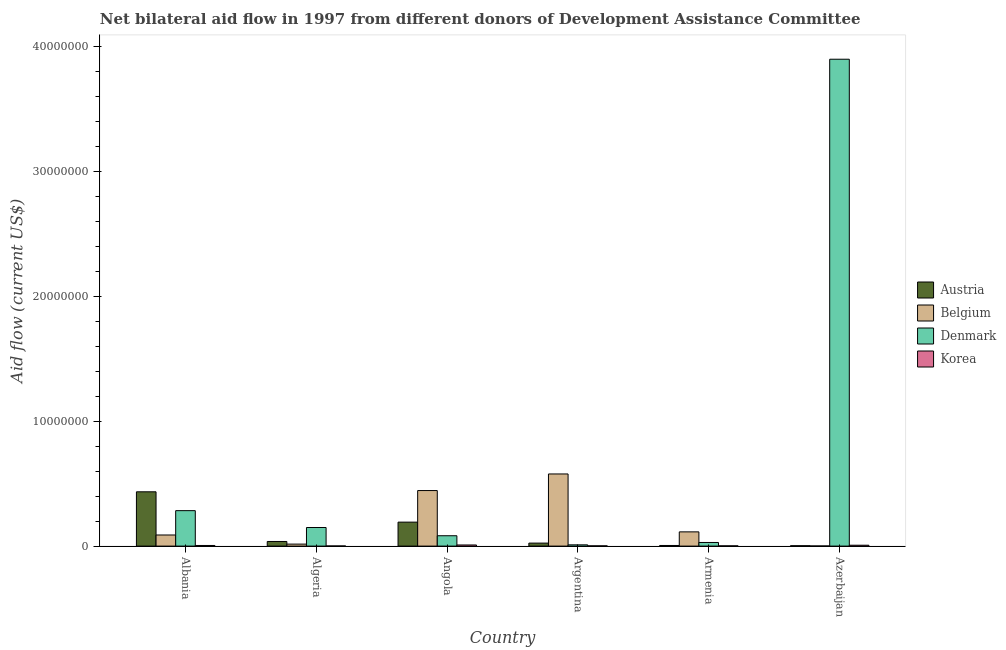How many different coloured bars are there?
Make the answer very short. 4. How many groups of bars are there?
Keep it short and to the point. 6. Are the number of bars per tick equal to the number of legend labels?
Offer a very short reply. Yes. Are the number of bars on each tick of the X-axis equal?
Keep it short and to the point. Yes. What is the label of the 2nd group of bars from the left?
Your response must be concise. Algeria. In how many cases, is the number of bars for a given country not equal to the number of legend labels?
Your answer should be very brief. 0. What is the amount of aid given by belgium in Azerbaijan?
Offer a terse response. 10000. Across all countries, what is the maximum amount of aid given by korea?
Offer a very short reply. 9.00e+04. Across all countries, what is the minimum amount of aid given by korea?
Your answer should be very brief. 10000. In which country was the amount of aid given by korea maximum?
Provide a short and direct response. Angola. In which country was the amount of aid given by denmark minimum?
Ensure brevity in your answer.  Argentina. What is the total amount of aid given by denmark in the graph?
Your answer should be compact. 4.46e+07. What is the difference between the amount of aid given by denmark in Algeria and that in Argentina?
Offer a very short reply. 1.39e+06. What is the difference between the amount of aid given by korea in Algeria and the amount of aid given by denmark in Armenia?
Keep it short and to the point. -2.80e+05. What is the average amount of aid given by austria per country?
Your answer should be very brief. 1.16e+06. What is the difference between the amount of aid given by denmark and amount of aid given by belgium in Armenia?
Make the answer very short. -8.50e+05. What is the ratio of the amount of aid given by denmark in Albania to that in Armenia?
Your answer should be very brief. 9.79. Is the amount of aid given by austria in Albania less than that in Armenia?
Give a very brief answer. No. Is the difference between the amount of aid given by belgium in Angola and Armenia greater than the difference between the amount of aid given by korea in Angola and Armenia?
Offer a terse response. Yes. What is the difference between the highest and the second highest amount of aid given by belgium?
Your answer should be compact. 1.33e+06. What is the difference between the highest and the lowest amount of aid given by denmark?
Provide a succinct answer. 3.89e+07. In how many countries, is the amount of aid given by korea greater than the average amount of aid given by korea taken over all countries?
Ensure brevity in your answer.  3. Is the sum of the amount of aid given by korea in Armenia and Azerbaijan greater than the maximum amount of aid given by belgium across all countries?
Offer a very short reply. No. Is it the case that in every country, the sum of the amount of aid given by korea and amount of aid given by denmark is greater than the sum of amount of aid given by austria and amount of aid given by belgium?
Your answer should be compact. Yes. What does the 2nd bar from the left in Algeria represents?
Offer a very short reply. Belgium. What does the 3rd bar from the right in Armenia represents?
Give a very brief answer. Belgium. Is it the case that in every country, the sum of the amount of aid given by austria and amount of aid given by belgium is greater than the amount of aid given by denmark?
Ensure brevity in your answer.  No. Are all the bars in the graph horizontal?
Your answer should be very brief. No. How many countries are there in the graph?
Provide a succinct answer. 6. Where does the legend appear in the graph?
Your answer should be very brief. Center right. How many legend labels are there?
Provide a succinct answer. 4. What is the title of the graph?
Your response must be concise. Net bilateral aid flow in 1997 from different donors of Development Assistance Committee. What is the label or title of the X-axis?
Provide a succinct answer. Country. What is the Aid flow (current US$) of Austria in Albania?
Offer a terse response. 4.35e+06. What is the Aid flow (current US$) in Belgium in Albania?
Offer a terse response. 8.90e+05. What is the Aid flow (current US$) in Denmark in Albania?
Offer a terse response. 2.84e+06. What is the Aid flow (current US$) in Austria in Algeria?
Your answer should be compact. 3.70e+05. What is the Aid flow (current US$) of Belgium in Algeria?
Your answer should be compact. 1.60e+05. What is the Aid flow (current US$) in Denmark in Algeria?
Give a very brief answer. 1.49e+06. What is the Aid flow (current US$) of Austria in Angola?
Ensure brevity in your answer.  1.92e+06. What is the Aid flow (current US$) of Belgium in Angola?
Your answer should be very brief. 4.45e+06. What is the Aid flow (current US$) in Denmark in Angola?
Offer a very short reply. 8.30e+05. What is the Aid flow (current US$) of Belgium in Argentina?
Make the answer very short. 5.78e+06. What is the Aid flow (current US$) of Korea in Argentina?
Your response must be concise. 2.00e+04. What is the Aid flow (current US$) of Austria in Armenia?
Your response must be concise. 5.00e+04. What is the Aid flow (current US$) of Belgium in Armenia?
Keep it short and to the point. 1.14e+06. What is the Aid flow (current US$) of Korea in Armenia?
Provide a succinct answer. 2.00e+04. What is the Aid flow (current US$) in Austria in Azerbaijan?
Your answer should be very brief. 3.00e+04. What is the Aid flow (current US$) in Denmark in Azerbaijan?
Your answer should be very brief. 3.90e+07. Across all countries, what is the maximum Aid flow (current US$) in Austria?
Your answer should be very brief. 4.35e+06. Across all countries, what is the maximum Aid flow (current US$) of Belgium?
Your response must be concise. 5.78e+06. Across all countries, what is the maximum Aid flow (current US$) of Denmark?
Your answer should be compact. 3.90e+07. Across all countries, what is the minimum Aid flow (current US$) in Austria?
Your answer should be compact. 3.00e+04. Across all countries, what is the minimum Aid flow (current US$) in Denmark?
Ensure brevity in your answer.  1.00e+05. Across all countries, what is the minimum Aid flow (current US$) in Korea?
Your answer should be compact. 10000. What is the total Aid flow (current US$) in Austria in the graph?
Your answer should be very brief. 6.96e+06. What is the total Aid flow (current US$) of Belgium in the graph?
Offer a very short reply. 1.24e+07. What is the total Aid flow (current US$) in Denmark in the graph?
Your answer should be very brief. 4.46e+07. What is the total Aid flow (current US$) in Korea in the graph?
Make the answer very short. 2.60e+05. What is the difference between the Aid flow (current US$) in Austria in Albania and that in Algeria?
Ensure brevity in your answer.  3.98e+06. What is the difference between the Aid flow (current US$) in Belgium in Albania and that in Algeria?
Give a very brief answer. 7.30e+05. What is the difference between the Aid flow (current US$) in Denmark in Albania and that in Algeria?
Make the answer very short. 1.35e+06. What is the difference between the Aid flow (current US$) in Korea in Albania and that in Algeria?
Keep it short and to the point. 4.00e+04. What is the difference between the Aid flow (current US$) in Austria in Albania and that in Angola?
Your answer should be very brief. 2.43e+06. What is the difference between the Aid flow (current US$) of Belgium in Albania and that in Angola?
Keep it short and to the point. -3.56e+06. What is the difference between the Aid flow (current US$) of Denmark in Albania and that in Angola?
Give a very brief answer. 2.01e+06. What is the difference between the Aid flow (current US$) in Austria in Albania and that in Argentina?
Offer a very short reply. 4.11e+06. What is the difference between the Aid flow (current US$) of Belgium in Albania and that in Argentina?
Give a very brief answer. -4.89e+06. What is the difference between the Aid flow (current US$) of Denmark in Albania and that in Argentina?
Provide a short and direct response. 2.74e+06. What is the difference between the Aid flow (current US$) in Austria in Albania and that in Armenia?
Offer a very short reply. 4.30e+06. What is the difference between the Aid flow (current US$) in Belgium in Albania and that in Armenia?
Your answer should be compact. -2.50e+05. What is the difference between the Aid flow (current US$) of Denmark in Albania and that in Armenia?
Your answer should be very brief. 2.55e+06. What is the difference between the Aid flow (current US$) of Korea in Albania and that in Armenia?
Provide a succinct answer. 3.00e+04. What is the difference between the Aid flow (current US$) of Austria in Albania and that in Azerbaijan?
Give a very brief answer. 4.32e+06. What is the difference between the Aid flow (current US$) in Belgium in Albania and that in Azerbaijan?
Keep it short and to the point. 8.80e+05. What is the difference between the Aid flow (current US$) in Denmark in Albania and that in Azerbaijan?
Ensure brevity in your answer.  -3.62e+07. What is the difference between the Aid flow (current US$) in Korea in Albania and that in Azerbaijan?
Give a very brief answer. -2.00e+04. What is the difference between the Aid flow (current US$) of Austria in Algeria and that in Angola?
Your response must be concise. -1.55e+06. What is the difference between the Aid flow (current US$) of Belgium in Algeria and that in Angola?
Offer a very short reply. -4.29e+06. What is the difference between the Aid flow (current US$) of Denmark in Algeria and that in Angola?
Ensure brevity in your answer.  6.60e+05. What is the difference between the Aid flow (current US$) of Belgium in Algeria and that in Argentina?
Your answer should be very brief. -5.62e+06. What is the difference between the Aid flow (current US$) in Denmark in Algeria and that in Argentina?
Provide a succinct answer. 1.39e+06. What is the difference between the Aid flow (current US$) in Austria in Algeria and that in Armenia?
Offer a terse response. 3.20e+05. What is the difference between the Aid flow (current US$) of Belgium in Algeria and that in Armenia?
Offer a very short reply. -9.80e+05. What is the difference between the Aid flow (current US$) in Denmark in Algeria and that in Armenia?
Ensure brevity in your answer.  1.20e+06. What is the difference between the Aid flow (current US$) in Korea in Algeria and that in Armenia?
Offer a very short reply. -10000. What is the difference between the Aid flow (current US$) of Denmark in Algeria and that in Azerbaijan?
Offer a very short reply. -3.75e+07. What is the difference between the Aid flow (current US$) of Austria in Angola and that in Argentina?
Offer a very short reply. 1.68e+06. What is the difference between the Aid flow (current US$) of Belgium in Angola and that in Argentina?
Ensure brevity in your answer.  -1.33e+06. What is the difference between the Aid flow (current US$) in Denmark in Angola and that in Argentina?
Ensure brevity in your answer.  7.30e+05. What is the difference between the Aid flow (current US$) in Austria in Angola and that in Armenia?
Your answer should be very brief. 1.87e+06. What is the difference between the Aid flow (current US$) of Belgium in Angola and that in Armenia?
Provide a short and direct response. 3.31e+06. What is the difference between the Aid flow (current US$) of Denmark in Angola and that in Armenia?
Provide a succinct answer. 5.40e+05. What is the difference between the Aid flow (current US$) in Korea in Angola and that in Armenia?
Provide a succinct answer. 7.00e+04. What is the difference between the Aid flow (current US$) in Austria in Angola and that in Azerbaijan?
Keep it short and to the point. 1.89e+06. What is the difference between the Aid flow (current US$) in Belgium in Angola and that in Azerbaijan?
Give a very brief answer. 4.44e+06. What is the difference between the Aid flow (current US$) in Denmark in Angola and that in Azerbaijan?
Give a very brief answer. -3.82e+07. What is the difference between the Aid flow (current US$) of Korea in Angola and that in Azerbaijan?
Your response must be concise. 2.00e+04. What is the difference between the Aid flow (current US$) of Austria in Argentina and that in Armenia?
Ensure brevity in your answer.  1.90e+05. What is the difference between the Aid flow (current US$) of Belgium in Argentina and that in Armenia?
Offer a terse response. 4.64e+06. What is the difference between the Aid flow (current US$) of Denmark in Argentina and that in Armenia?
Make the answer very short. -1.90e+05. What is the difference between the Aid flow (current US$) in Austria in Argentina and that in Azerbaijan?
Offer a terse response. 2.10e+05. What is the difference between the Aid flow (current US$) in Belgium in Argentina and that in Azerbaijan?
Give a very brief answer. 5.77e+06. What is the difference between the Aid flow (current US$) in Denmark in Argentina and that in Azerbaijan?
Your answer should be very brief. -3.89e+07. What is the difference between the Aid flow (current US$) of Austria in Armenia and that in Azerbaijan?
Ensure brevity in your answer.  2.00e+04. What is the difference between the Aid flow (current US$) of Belgium in Armenia and that in Azerbaijan?
Ensure brevity in your answer.  1.13e+06. What is the difference between the Aid flow (current US$) in Denmark in Armenia and that in Azerbaijan?
Make the answer very short. -3.87e+07. What is the difference between the Aid flow (current US$) of Austria in Albania and the Aid flow (current US$) of Belgium in Algeria?
Your response must be concise. 4.19e+06. What is the difference between the Aid flow (current US$) of Austria in Albania and the Aid flow (current US$) of Denmark in Algeria?
Provide a short and direct response. 2.86e+06. What is the difference between the Aid flow (current US$) in Austria in Albania and the Aid flow (current US$) in Korea in Algeria?
Offer a very short reply. 4.34e+06. What is the difference between the Aid flow (current US$) in Belgium in Albania and the Aid flow (current US$) in Denmark in Algeria?
Offer a terse response. -6.00e+05. What is the difference between the Aid flow (current US$) of Belgium in Albania and the Aid flow (current US$) of Korea in Algeria?
Ensure brevity in your answer.  8.80e+05. What is the difference between the Aid flow (current US$) in Denmark in Albania and the Aid flow (current US$) in Korea in Algeria?
Make the answer very short. 2.83e+06. What is the difference between the Aid flow (current US$) of Austria in Albania and the Aid flow (current US$) of Denmark in Angola?
Your response must be concise. 3.52e+06. What is the difference between the Aid flow (current US$) in Austria in Albania and the Aid flow (current US$) in Korea in Angola?
Your answer should be very brief. 4.26e+06. What is the difference between the Aid flow (current US$) in Belgium in Albania and the Aid flow (current US$) in Korea in Angola?
Keep it short and to the point. 8.00e+05. What is the difference between the Aid flow (current US$) of Denmark in Albania and the Aid flow (current US$) of Korea in Angola?
Give a very brief answer. 2.75e+06. What is the difference between the Aid flow (current US$) in Austria in Albania and the Aid flow (current US$) in Belgium in Argentina?
Provide a succinct answer. -1.43e+06. What is the difference between the Aid flow (current US$) of Austria in Albania and the Aid flow (current US$) of Denmark in Argentina?
Keep it short and to the point. 4.25e+06. What is the difference between the Aid flow (current US$) of Austria in Albania and the Aid flow (current US$) of Korea in Argentina?
Keep it short and to the point. 4.33e+06. What is the difference between the Aid flow (current US$) in Belgium in Albania and the Aid flow (current US$) in Denmark in Argentina?
Offer a very short reply. 7.90e+05. What is the difference between the Aid flow (current US$) of Belgium in Albania and the Aid flow (current US$) of Korea in Argentina?
Offer a terse response. 8.70e+05. What is the difference between the Aid flow (current US$) of Denmark in Albania and the Aid flow (current US$) of Korea in Argentina?
Provide a short and direct response. 2.82e+06. What is the difference between the Aid flow (current US$) of Austria in Albania and the Aid flow (current US$) of Belgium in Armenia?
Offer a terse response. 3.21e+06. What is the difference between the Aid flow (current US$) in Austria in Albania and the Aid flow (current US$) in Denmark in Armenia?
Offer a very short reply. 4.06e+06. What is the difference between the Aid flow (current US$) of Austria in Albania and the Aid flow (current US$) of Korea in Armenia?
Offer a terse response. 4.33e+06. What is the difference between the Aid flow (current US$) in Belgium in Albania and the Aid flow (current US$) in Korea in Armenia?
Your answer should be compact. 8.70e+05. What is the difference between the Aid flow (current US$) of Denmark in Albania and the Aid flow (current US$) of Korea in Armenia?
Ensure brevity in your answer.  2.82e+06. What is the difference between the Aid flow (current US$) in Austria in Albania and the Aid flow (current US$) in Belgium in Azerbaijan?
Your answer should be compact. 4.34e+06. What is the difference between the Aid flow (current US$) of Austria in Albania and the Aid flow (current US$) of Denmark in Azerbaijan?
Keep it short and to the point. -3.47e+07. What is the difference between the Aid flow (current US$) in Austria in Albania and the Aid flow (current US$) in Korea in Azerbaijan?
Offer a terse response. 4.28e+06. What is the difference between the Aid flow (current US$) in Belgium in Albania and the Aid flow (current US$) in Denmark in Azerbaijan?
Offer a terse response. -3.81e+07. What is the difference between the Aid flow (current US$) of Belgium in Albania and the Aid flow (current US$) of Korea in Azerbaijan?
Offer a very short reply. 8.20e+05. What is the difference between the Aid flow (current US$) of Denmark in Albania and the Aid flow (current US$) of Korea in Azerbaijan?
Offer a terse response. 2.77e+06. What is the difference between the Aid flow (current US$) in Austria in Algeria and the Aid flow (current US$) in Belgium in Angola?
Your answer should be very brief. -4.08e+06. What is the difference between the Aid flow (current US$) of Austria in Algeria and the Aid flow (current US$) of Denmark in Angola?
Keep it short and to the point. -4.60e+05. What is the difference between the Aid flow (current US$) in Austria in Algeria and the Aid flow (current US$) in Korea in Angola?
Your answer should be very brief. 2.80e+05. What is the difference between the Aid flow (current US$) of Belgium in Algeria and the Aid flow (current US$) of Denmark in Angola?
Your response must be concise. -6.70e+05. What is the difference between the Aid flow (current US$) in Denmark in Algeria and the Aid flow (current US$) in Korea in Angola?
Provide a short and direct response. 1.40e+06. What is the difference between the Aid flow (current US$) in Austria in Algeria and the Aid flow (current US$) in Belgium in Argentina?
Provide a short and direct response. -5.41e+06. What is the difference between the Aid flow (current US$) in Austria in Algeria and the Aid flow (current US$) in Denmark in Argentina?
Ensure brevity in your answer.  2.70e+05. What is the difference between the Aid flow (current US$) of Denmark in Algeria and the Aid flow (current US$) of Korea in Argentina?
Your answer should be very brief. 1.47e+06. What is the difference between the Aid flow (current US$) in Austria in Algeria and the Aid flow (current US$) in Belgium in Armenia?
Offer a terse response. -7.70e+05. What is the difference between the Aid flow (current US$) of Austria in Algeria and the Aid flow (current US$) of Denmark in Armenia?
Offer a terse response. 8.00e+04. What is the difference between the Aid flow (current US$) in Belgium in Algeria and the Aid flow (current US$) in Denmark in Armenia?
Offer a terse response. -1.30e+05. What is the difference between the Aid flow (current US$) in Denmark in Algeria and the Aid flow (current US$) in Korea in Armenia?
Keep it short and to the point. 1.47e+06. What is the difference between the Aid flow (current US$) of Austria in Algeria and the Aid flow (current US$) of Belgium in Azerbaijan?
Make the answer very short. 3.60e+05. What is the difference between the Aid flow (current US$) of Austria in Algeria and the Aid flow (current US$) of Denmark in Azerbaijan?
Keep it short and to the point. -3.86e+07. What is the difference between the Aid flow (current US$) in Belgium in Algeria and the Aid flow (current US$) in Denmark in Azerbaijan?
Keep it short and to the point. -3.88e+07. What is the difference between the Aid flow (current US$) of Denmark in Algeria and the Aid flow (current US$) of Korea in Azerbaijan?
Your response must be concise. 1.42e+06. What is the difference between the Aid flow (current US$) in Austria in Angola and the Aid flow (current US$) in Belgium in Argentina?
Your answer should be compact. -3.86e+06. What is the difference between the Aid flow (current US$) of Austria in Angola and the Aid flow (current US$) of Denmark in Argentina?
Your response must be concise. 1.82e+06. What is the difference between the Aid flow (current US$) in Austria in Angola and the Aid flow (current US$) in Korea in Argentina?
Your answer should be very brief. 1.90e+06. What is the difference between the Aid flow (current US$) of Belgium in Angola and the Aid flow (current US$) of Denmark in Argentina?
Ensure brevity in your answer.  4.35e+06. What is the difference between the Aid flow (current US$) in Belgium in Angola and the Aid flow (current US$) in Korea in Argentina?
Keep it short and to the point. 4.43e+06. What is the difference between the Aid flow (current US$) of Denmark in Angola and the Aid flow (current US$) of Korea in Argentina?
Provide a succinct answer. 8.10e+05. What is the difference between the Aid flow (current US$) of Austria in Angola and the Aid flow (current US$) of Belgium in Armenia?
Offer a terse response. 7.80e+05. What is the difference between the Aid flow (current US$) in Austria in Angola and the Aid flow (current US$) in Denmark in Armenia?
Ensure brevity in your answer.  1.63e+06. What is the difference between the Aid flow (current US$) in Austria in Angola and the Aid flow (current US$) in Korea in Armenia?
Offer a terse response. 1.90e+06. What is the difference between the Aid flow (current US$) of Belgium in Angola and the Aid flow (current US$) of Denmark in Armenia?
Make the answer very short. 4.16e+06. What is the difference between the Aid flow (current US$) in Belgium in Angola and the Aid flow (current US$) in Korea in Armenia?
Give a very brief answer. 4.43e+06. What is the difference between the Aid flow (current US$) of Denmark in Angola and the Aid flow (current US$) of Korea in Armenia?
Provide a short and direct response. 8.10e+05. What is the difference between the Aid flow (current US$) of Austria in Angola and the Aid flow (current US$) of Belgium in Azerbaijan?
Your response must be concise. 1.91e+06. What is the difference between the Aid flow (current US$) of Austria in Angola and the Aid flow (current US$) of Denmark in Azerbaijan?
Make the answer very short. -3.71e+07. What is the difference between the Aid flow (current US$) in Austria in Angola and the Aid flow (current US$) in Korea in Azerbaijan?
Keep it short and to the point. 1.85e+06. What is the difference between the Aid flow (current US$) in Belgium in Angola and the Aid flow (current US$) in Denmark in Azerbaijan?
Your answer should be compact. -3.46e+07. What is the difference between the Aid flow (current US$) of Belgium in Angola and the Aid flow (current US$) of Korea in Azerbaijan?
Make the answer very short. 4.38e+06. What is the difference between the Aid flow (current US$) in Denmark in Angola and the Aid flow (current US$) in Korea in Azerbaijan?
Your response must be concise. 7.60e+05. What is the difference between the Aid flow (current US$) in Austria in Argentina and the Aid flow (current US$) in Belgium in Armenia?
Keep it short and to the point. -9.00e+05. What is the difference between the Aid flow (current US$) of Austria in Argentina and the Aid flow (current US$) of Denmark in Armenia?
Give a very brief answer. -5.00e+04. What is the difference between the Aid flow (current US$) in Belgium in Argentina and the Aid flow (current US$) in Denmark in Armenia?
Give a very brief answer. 5.49e+06. What is the difference between the Aid flow (current US$) in Belgium in Argentina and the Aid flow (current US$) in Korea in Armenia?
Ensure brevity in your answer.  5.76e+06. What is the difference between the Aid flow (current US$) of Denmark in Argentina and the Aid flow (current US$) of Korea in Armenia?
Your response must be concise. 8.00e+04. What is the difference between the Aid flow (current US$) in Austria in Argentina and the Aid flow (current US$) in Belgium in Azerbaijan?
Provide a succinct answer. 2.30e+05. What is the difference between the Aid flow (current US$) of Austria in Argentina and the Aid flow (current US$) of Denmark in Azerbaijan?
Provide a succinct answer. -3.88e+07. What is the difference between the Aid flow (current US$) of Austria in Argentina and the Aid flow (current US$) of Korea in Azerbaijan?
Ensure brevity in your answer.  1.70e+05. What is the difference between the Aid flow (current US$) of Belgium in Argentina and the Aid flow (current US$) of Denmark in Azerbaijan?
Your response must be concise. -3.32e+07. What is the difference between the Aid flow (current US$) of Belgium in Argentina and the Aid flow (current US$) of Korea in Azerbaijan?
Give a very brief answer. 5.71e+06. What is the difference between the Aid flow (current US$) in Austria in Armenia and the Aid flow (current US$) in Denmark in Azerbaijan?
Provide a short and direct response. -3.90e+07. What is the difference between the Aid flow (current US$) in Belgium in Armenia and the Aid flow (current US$) in Denmark in Azerbaijan?
Keep it short and to the point. -3.79e+07. What is the difference between the Aid flow (current US$) of Belgium in Armenia and the Aid flow (current US$) of Korea in Azerbaijan?
Your response must be concise. 1.07e+06. What is the average Aid flow (current US$) of Austria per country?
Make the answer very short. 1.16e+06. What is the average Aid flow (current US$) in Belgium per country?
Give a very brief answer. 2.07e+06. What is the average Aid flow (current US$) in Denmark per country?
Offer a terse response. 7.43e+06. What is the average Aid flow (current US$) of Korea per country?
Provide a short and direct response. 4.33e+04. What is the difference between the Aid flow (current US$) of Austria and Aid flow (current US$) of Belgium in Albania?
Your answer should be compact. 3.46e+06. What is the difference between the Aid flow (current US$) in Austria and Aid flow (current US$) in Denmark in Albania?
Your answer should be very brief. 1.51e+06. What is the difference between the Aid flow (current US$) in Austria and Aid flow (current US$) in Korea in Albania?
Offer a terse response. 4.30e+06. What is the difference between the Aid flow (current US$) in Belgium and Aid flow (current US$) in Denmark in Albania?
Provide a short and direct response. -1.95e+06. What is the difference between the Aid flow (current US$) in Belgium and Aid flow (current US$) in Korea in Albania?
Offer a very short reply. 8.40e+05. What is the difference between the Aid flow (current US$) of Denmark and Aid flow (current US$) of Korea in Albania?
Provide a succinct answer. 2.79e+06. What is the difference between the Aid flow (current US$) of Austria and Aid flow (current US$) of Denmark in Algeria?
Give a very brief answer. -1.12e+06. What is the difference between the Aid flow (current US$) of Belgium and Aid flow (current US$) of Denmark in Algeria?
Your answer should be very brief. -1.33e+06. What is the difference between the Aid flow (current US$) in Belgium and Aid flow (current US$) in Korea in Algeria?
Provide a short and direct response. 1.50e+05. What is the difference between the Aid flow (current US$) of Denmark and Aid flow (current US$) of Korea in Algeria?
Keep it short and to the point. 1.48e+06. What is the difference between the Aid flow (current US$) of Austria and Aid flow (current US$) of Belgium in Angola?
Provide a succinct answer. -2.53e+06. What is the difference between the Aid flow (current US$) in Austria and Aid flow (current US$) in Denmark in Angola?
Offer a very short reply. 1.09e+06. What is the difference between the Aid flow (current US$) of Austria and Aid flow (current US$) of Korea in Angola?
Keep it short and to the point. 1.83e+06. What is the difference between the Aid flow (current US$) in Belgium and Aid flow (current US$) in Denmark in Angola?
Make the answer very short. 3.62e+06. What is the difference between the Aid flow (current US$) of Belgium and Aid flow (current US$) of Korea in Angola?
Provide a short and direct response. 4.36e+06. What is the difference between the Aid flow (current US$) in Denmark and Aid flow (current US$) in Korea in Angola?
Give a very brief answer. 7.40e+05. What is the difference between the Aid flow (current US$) in Austria and Aid flow (current US$) in Belgium in Argentina?
Provide a short and direct response. -5.54e+06. What is the difference between the Aid flow (current US$) of Austria and Aid flow (current US$) of Denmark in Argentina?
Make the answer very short. 1.40e+05. What is the difference between the Aid flow (current US$) of Austria and Aid flow (current US$) of Korea in Argentina?
Offer a terse response. 2.20e+05. What is the difference between the Aid flow (current US$) of Belgium and Aid flow (current US$) of Denmark in Argentina?
Your answer should be very brief. 5.68e+06. What is the difference between the Aid flow (current US$) in Belgium and Aid flow (current US$) in Korea in Argentina?
Keep it short and to the point. 5.76e+06. What is the difference between the Aid flow (current US$) in Denmark and Aid flow (current US$) in Korea in Argentina?
Offer a very short reply. 8.00e+04. What is the difference between the Aid flow (current US$) in Austria and Aid flow (current US$) in Belgium in Armenia?
Provide a succinct answer. -1.09e+06. What is the difference between the Aid flow (current US$) in Austria and Aid flow (current US$) in Denmark in Armenia?
Your response must be concise. -2.40e+05. What is the difference between the Aid flow (current US$) in Austria and Aid flow (current US$) in Korea in Armenia?
Your answer should be very brief. 3.00e+04. What is the difference between the Aid flow (current US$) of Belgium and Aid flow (current US$) of Denmark in Armenia?
Give a very brief answer. 8.50e+05. What is the difference between the Aid flow (current US$) of Belgium and Aid flow (current US$) of Korea in Armenia?
Your answer should be very brief. 1.12e+06. What is the difference between the Aid flow (current US$) in Austria and Aid flow (current US$) in Denmark in Azerbaijan?
Ensure brevity in your answer.  -3.90e+07. What is the difference between the Aid flow (current US$) of Belgium and Aid flow (current US$) of Denmark in Azerbaijan?
Your answer should be compact. -3.90e+07. What is the difference between the Aid flow (current US$) of Denmark and Aid flow (current US$) of Korea in Azerbaijan?
Offer a very short reply. 3.89e+07. What is the ratio of the Aid flow (current US$) in Austria in Albania to that in Algeria?
Give a very brief answer. 11.76. What is the ratio of the Aid flow (current US$) of Belgium in Albania to that in Algeria?
Provide a short and direct response. 5.56. What is the ratio of the Aid flow (current US$) of Denmark in Albania to that in Algeria?
Ensure brevity in your answer.  1.91. What is the ratio of the Aid flow (current US$) in Korea in Albania to that in Algeria?
Ensure brevity in your answer.  5. What is the ratio of the Aid flow (current US$) in Austria in Albania to that in Angola?
Give a very brief answer. 2.27. What is the ratio of the Aid flow (current US$) in Denmark in Albania to that in Angola?
Your answer should be compact. 3.42. What is the ratio of the Aid flow (current US$) in Korea in Albania to that in Angola?
Keep it short and to the point. 0.56. What is the ratio of the Aid flow (current US$) of Austria in Albania to that in Argentina?
Make the answer very short. 18.12. What is the ratio of the Aid flow (current US$) in Belgium in Albania to that in Argentina?
Offer a very short reply. 0.15. What is the ratio of the Aid flow (current US$) in Denmark in Albania to that in Argentina?
Your answer should be compact. 28.4. What is the ratio of the Aid flow (current US$) of Korea in Albania to that in Argentina?
Your answer should be compact. 2.5. What is the ratio of the Aid flow (current US$) in Belgium in Albania to that in Armenia?
Provide a short and direct response. 0.78. What is the ratio of the Aid flow (current US$) of Denmark in Albania to that in Armenia?
Provide a succinct answer. 9.79. What is the ratio of the Aid flow (current US$) of Austria in Albania to that in Azerbaijan?
Keep it short and to the point. 145. What is the ratio of the Aid flow (current US$) of Belgium in Albania to that in Azerbaijan?
Your answer should be very brief. 89. What is the ratio of the Aid flow (current US$) of Denmark in Albania to that in Azerbaijan?
Give a very brief answer. 0.07. What is the ratio of the Aid flow (current US$) of Korea in Albania to that in Azerbaijan?
Provide a succinct answer. 0.71. What is the ratio of the Aid flow (current US$) in Austria in Algeria to that in Angola?
Your response must be concise. 0.19. What is the ratio of the Aid flow (current US$) in Belgium in Algeria to that in Angola?
Make the answer very short. 0.04. What is the ratio of the Aid flow (current US$) in Denmark in Algeria to that in Angola?
Keep it short and to the point. 1.8. What is the ratio of the Aid flow (current US$) in Korea in Algeria to that in Angola?
Provide a short and direct response. 0.11. What is the ratio of the Aid flow (current US$) of Austria in Algeria to that in Argentina?
Provide a succinct answer. 1.54. What is the ratio of the Aid flow (current US$) in Belgium in Algeria to that in Argentina?
Make the answer very short. 0.03. What is the ratio of the Aid flow (current US$) of Belgium in Algeria to that in Armenia?
Make the answer very short. 0.14. What is the ratio of the Aid flow (current US$) of Denmark in Algeria to that in Armenia?
Offer a very short reply. 5.14. What is the ratio of the Aid flow (current US$) of Korea in Algeria to that in Armenia?
Offer a very short reply. 0.5. What is the ratio of the Aid flow (current US$) of Austria in Algeria to that in Azerbaijan?
Provide a succinct answer. 12.33. What is the ratio of the Aid flow (current US$) of Denmark in Algeria to that in Azerbaijan?
Your answer should be compact. 0.04. What is the ratio of the Aid flow (current US$) in Korea in Algeria to that in Azerbaijan?
Your answer should be very brief. 0.14. What is the ratio of the Aid flow (current US$) in Belgium in Angola to that in Argentina?
Give a very brief answer. 0.77. What is the ratio of the Aid flow (current US$) of Denmark in Angola to that in Argentina?
Your answer should be very brief. 8.3. What is the ratio of the Aid flow (current US$) in Korea in Angola to that in Argentina?
Your answer should be compact. 4.5. What is the ratio of the Aid flow (current US$) in Austria in Angola to that in Armenia?
Keep it short and to the point. 38.4. What is the ratio of the Aid flow (current US$) of Belgium in Angola to that in Armenia?
Provide a short and direct response. 3.9. What is the ratio of the Aid flow (current US$) in Denmark in Angola to that in Armenia?
Provide a short and direct response. 2.86. What is the ratio of the Aid flow (current US$) of Austria in Angola to that in Azerbaijan?
Your answer should be compact. 64. What is the ratio of the Aid flow (current US$) in Belgium in Angola to that in Azerbaijan?
Your answer should be compact. 445. What is the ratio of the Aid flow (current US$) in Denmark in Angola to that in Azerbaijan?
Keep it short and to the point. 0.02. What is the ratio of the Aid flow (current US$) in Belgium in Argentina to that in Armenia?
Provide a short and direct response. 5.07. What is the ratio of the Aid flow (current US$) of Denmark in Argentina to that in Armenia?
Offer a terse response. 0.34. What is the ratio of the Aid flow (current US$) in Korea in Argentina to that in Armenia?
Your response must be concise. 1. What is the ratio of the Aid flow (current US$) of Austria in Argentina to that in Azerbaijan?
Offer a terse response. 8. What is the ratio of the Aid flow (current US$) in Belgium in Argentina to that in Azerbaijan?
Your answer should be very brief. 578. What is the ratio of the Aid flow (current US$) of Denmark in Argentina to that in Azerbaijan?
Give a very brief answer. 0. What is the ratio of the Aid flow (current US$) of Korea in Argentina to that in Azerbaijan?
Your response must be concise. 0.29. What is the ratio of the Aid flow (current US$) of Belgium in Armenia to that in Azerbaijan?
Provide a succinct answer. 114. What is the ratio of the Aid flow (current US$) in Denmark in Armenia to that in Azerbaijan?
Your answer should be compact. 0.01. What is the ratio of the Aid flow (current US$) in Korea in Armenia to that in Azerbaijan?
Keep it short and to the point. 0.29. What is the difference between the highest and the second highest Aid flow (current US$) of Austria?
Provide a succinct answer. 2.43e+06. What is the difference between the highest and the second highest Aid flow (current US$) of Belgium?
Give a very brief answer. 1.33e+06. What is the difference between the highest and the second highest Aid flow (current US$) in Denmark?
Your response must be concise. 3.62e+07. What is the difference between the highest and the second highest Aid flow (current US$) of Korea?
Provide a succinct answer. 2.00e+04. What is the difference between the highest and the lowest Aid flow (current US$) of Austria?
Your answer should be compact. 4.32e+06. What is the difference between the highest and the lowest Aid flow (current US$) of Belgium?
Ensure brevity in your answer.  5.77e+06. What is the difference between the highest and the lowest Aid flow (current US$) of Denmark?
Your answer should be compact. 3.89e+07. 